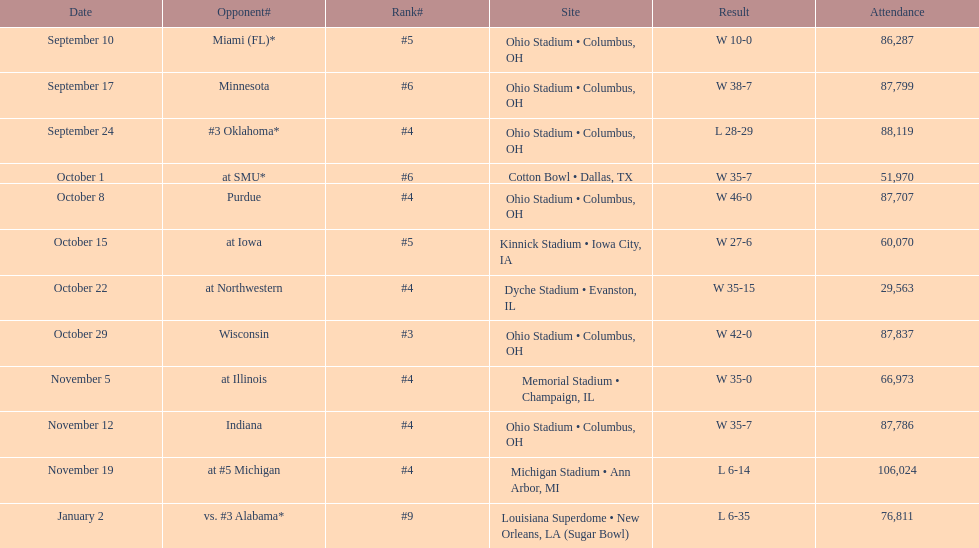How many dates are present on the graph? 12. Give me the full table as a dictionary. {'header': ['Date', 'Opponent#', 'Rank#', 'Site', 'Result', 'Attendance'], 'rows': [['September 10', 'Miami (FL)*', '#5', 'Ohio Stadium • Columbus, OH', 'W\xa010-0', '86,287'], ['September 17', 'Minnesota', '#6', 'Ohio Stadium • Columbus, OH', 'W\xa038-7', '87,799'], ['September 24', '#3\xa0Oklahoma*', '#4', 'Ohio Stadium • Columbus, OH', 'L\xa028-29', '88,119'], ['October 1', 'at\xa0SMU*', '#6', 'Cotton Bowl • Dallas, TX', 'W\xa035-7', '51,970'], ['October 8', 'Purdue', '#4', 'Ohio Stadium • Columbus, OH', 'W\xa046-0', '87,707'], ['October 15', 'at\xa0Iowa', '#5', 'Kinnick Stadium • Iowa City, IA', 'W\xa027-6', '60,070'], ['October 22', 'at\xa0Northwestern', '#4', 'Dyche Stadium • Evanston, IL', 'W\xa035-15', '29,563'], ['October 29', 'Wisconsin', '#3', 'Ohio Stadium • Columbus, OH', 'W\xa042-0', '87,837'], ['November 5', 'at\xa0Illinois', '#4', 'Memorial Stadium • Champaign, IL', 'W\xa035-0', '66,973'], ['November 12', 'Indiana', '#4', 'Ohio Stadium • Columbus, OH', 'W\xa035-7', '87,786'], ['November 19', 'at\xa0#5\xa0Michigan', '#4', 'Michigan Stadium • Ann Arbor, MI', 'L\xa06-14', '106,024'], ['January 2', 'vs.\xa0#3\xa0Alabama*', '#9', 'Louisiana Superdome • New Orleans, LA (Sugar Bowl)', 'L\xa06-35', '76,811']]} 